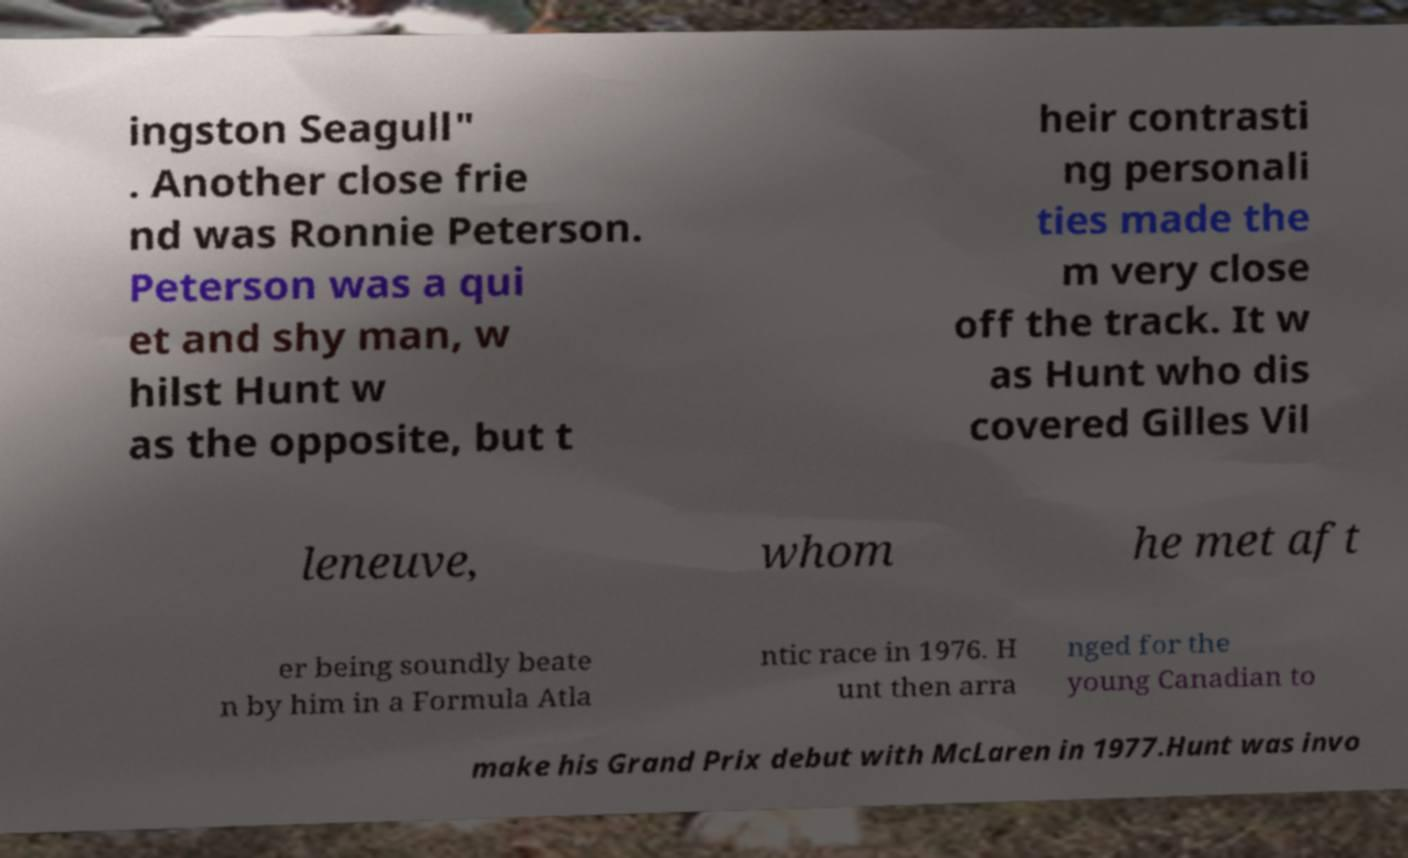What messages or text are displayed in this image? I need them in a readable, typed format. ingston Seagull" . Another close frie nd was Ronnie Peterson. Peterson was a qui et and shy man, w hilst Hunt w as the opposite, but t heir contrasti ng personali ties made the m very close off the track. It w as Hunt who dis covered Gilles Vil leneuve, whom he met aft er being soundly beate n by him in a Formula Atla ntic race in 1976. H unt then arra nged for the young Canadian to make his Grand Prix debut with McLaren in 1977.Hunt was invo 